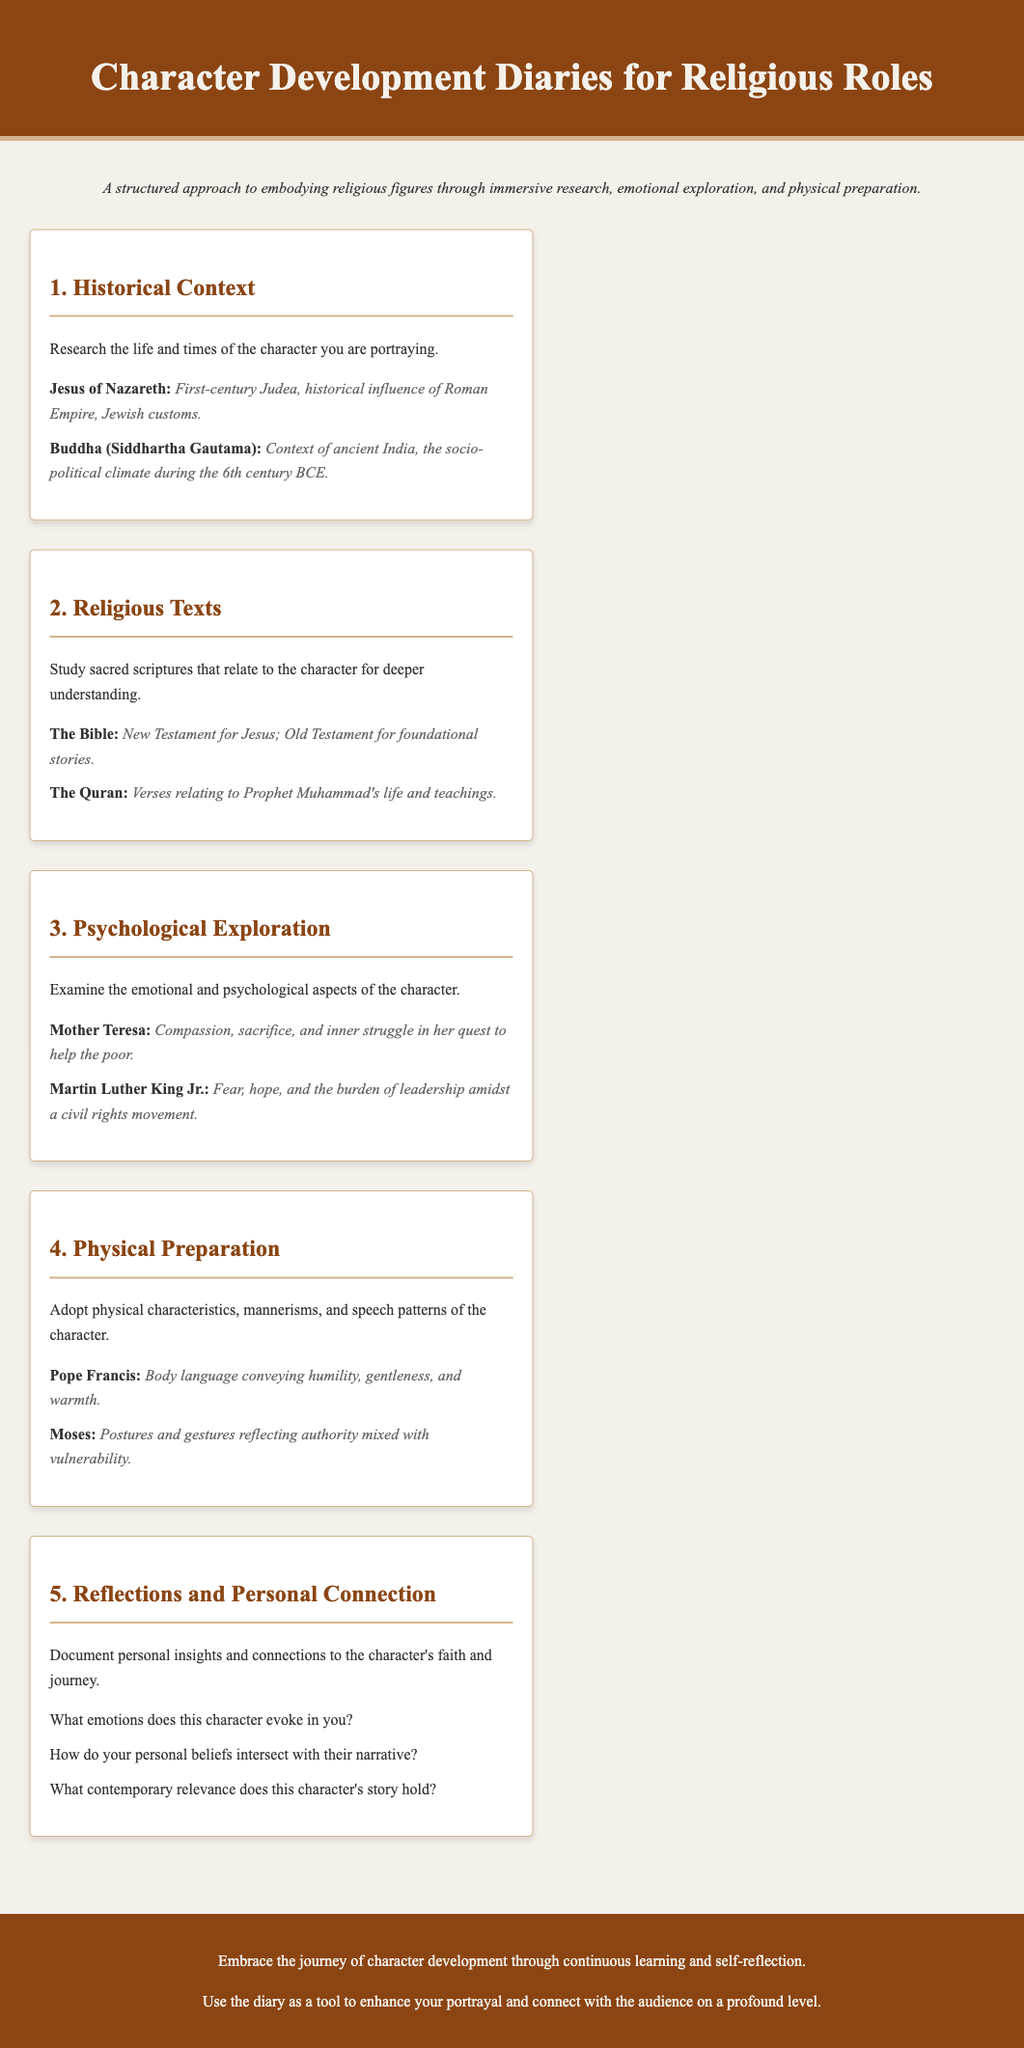What is the title of the document? The title is displayed prominently at the top of the document, indicating the focus of the content.
Answer: Character Development Diaries for Religious Roles What is the first menu item? The first menu item is the initial topic listed in the structured approach for character development.
Answer: Historical Context Which religious figure is associated with the phrase "First-century Judea"? This phrase is intended to provide context for the life and times of a specific religious person.
Answer: Jesus of Nazareth What does the section on "Religious Texts" suggest for deepening understanding? This section encourages examining sacred writings relevant to the character being portrayed.
Answer: Study sacred scriptures What psychological aspect is explored in relation to Mother Teresa? This aspect focuses on a specific emotional quality attributed to her character's journey.
Answer: Compassion How many items are listed under "Physical Preparation"? The count of the topics discussed can be derived from the elements featured in this section.
Answer: 2 What kind of insights does the "Reflections and Personal Connection" section encourage? This section emphasizes personal emotions and narratives linked with the character's journey.
Answer: Document personal insights What feeling does Martin Luther King Jr. evoke according to the "Psychological Exploration"? The phrase identifies a significant emotional state he experienced amidst his leadership role.
Answer: Fear, hope What is the general advice provided in the footer? The footer encapsulates overall guidance for utilizing the diaries effectively in character development.
Answer: Embrace the journey of character development 